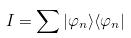<formula> <loc_0><loc_0><loc_500><loc_500>I = \sum | \varphi _ { n } \rangle \langle \varphi _ { n } |</formula> 